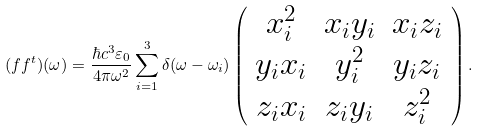<formula> <loc_0><loc_0><loc_500><loc_500>( f f ^ { t } ) ( \omega ) = \frac { \hbar { c } ^ { 3 } \varepsilon _ { 0 } } { 4 \pi \omega ^ { 2 } } \sum _ { i = 1 } ^ { 3 } \delta ( \omega - \omega _ { i } ) \left ( \begin{array} { c c c } x _ { i } ^ { 2 } & x _ { i } y _ { i } & x _ { i } z _ { i } \\ y _ { i } x _ { i } & y _ { i } ^ { 2 } & y _ { i } z _ { i } \\ z _ { i } x _ { i } & z _ { i } y _ { i } & z _ { i } ^ { 2 } \end{array} \right ) .</formula> 